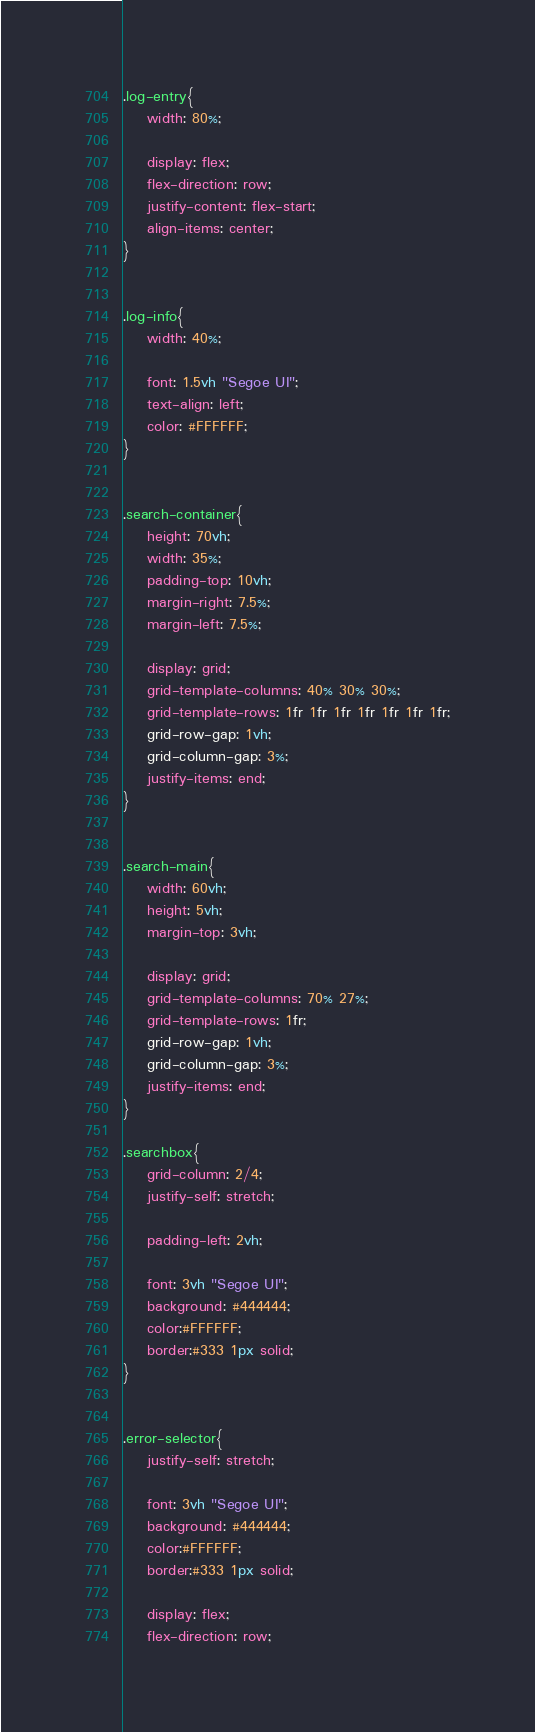Convert code to text. <code><loc_0><loc_0><loc_500><loc_500><_CSS_>.log-entry{
	width: 80%;

	display: flex;
	flex-direction: row;
	justify-content: flex-start;
	align-items: center;
}


.log-info{
	width: 40%;

	font: 1.5vh "Segoe UI";
	text-align: left;
	color: #FFFFFF;
}


.search-container{
	height: 70vh;
	width: 35%;
	padding-top: 10vh;
	margin-right: 7.5%;
	margin-left: 7.5%;

	display: grid;
	grid-template-columns: 40% 30% 30%;
	grid-template-rows: 1fr 1fr 1fr 1fr 1fr 1fr 1fr;
	grid-row-gap: 1vh;
	grid-column-gap: 3%;
	justify-items: end;
}


.search-main{
	width: 60vh;
	height: 5vh;
	margin-top: 3vh;

	display: grid;
	grid-template-columns: 70% 27%;
	grid-template-rows: 1fr;
	grid-row-gap: 1vh;
	grid-column-gap: 3%;
	justify-items: end;
}

.searchbox{
	grid-column: 2/4;
	justify-self: stretch;

	padding-left: 2vh;

	font: 3vh "Segoe UI";
	background: #444444;
	color:#FFFFFF;
	border:#333 1px solid;
}


.error-selector{
	justify-self: stretch;

	font: 3vh "Segoe UI";
	background: #444444;
	color:#FFFFFF;
	border:#333 1px solid;

	display: flex;
	flex-direction: row;</code> 